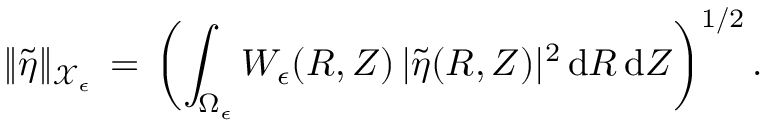Convert formula to latex. <formula><loc_0><loc_0><loc_500><loc_500>\| \tilde { \eta } \| _ { \mathcal { X } _ { \epsilon } } \, = \, \left ( \int _ { \Omega _ { \epsilon } } W _ { \epsilon } ( R , Z ) \, | \tilde { \eta } ( R , Z ) | ^ { 2 } \, d R \, d Z \right ) ^ { 1 / 2 } \, .</formula> 